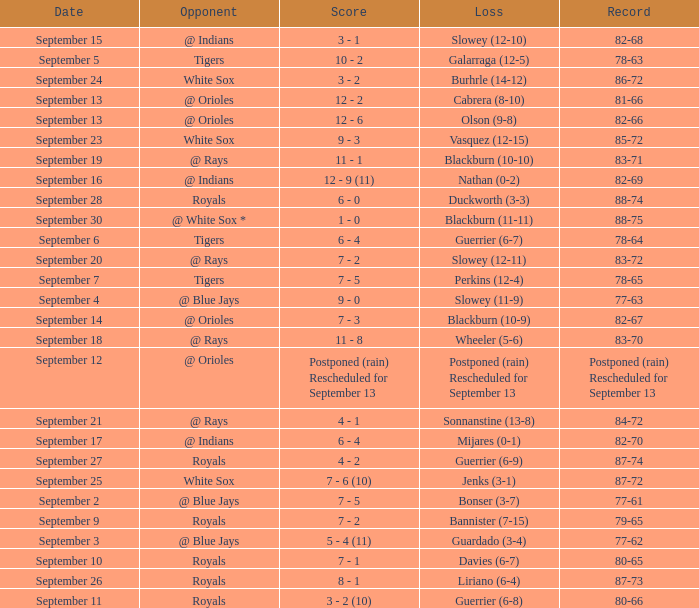What opponent has the record of 78-63? Tigers. 